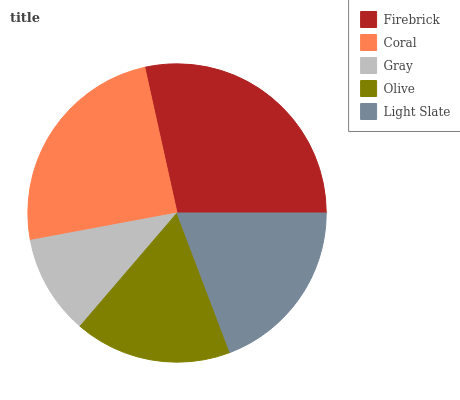Is Gray the minimum?
Answer yes or no. Yes. Is Firebrick the maximum?
Answer yes or no. Yes. Is Coral the minimum?
Answer yes or no. No. Is Coral the maximum?
Answer yes or no. No. Is Firebrick greater than Coral?
Answer yes or no. Yes. Is Coral less than Firebrick?
Answer yes or no. Yes. Is Coral greater than Firebrick?
Answer yes or no. No. Is Firebrick less than Coral?
Answer yes or no. No. Is Light Slate the high median?
Answer yes or no. Yes. Is Light Slate the low median?
Answer yes or no. Yes. Is Firebrick the high median?
Answer yes or no. No. Is Coral the low median?
Answer yes or no. No. 